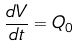Convert formula to latex. <formula><loc_0><loc_0><loc_500><loc_500>\frac { d V } { d t } = Q _ { 0 }</formula> 